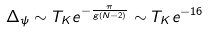<formula> <loc_0><loc_0><loc_500><loc_500>\Delta _ { \psi } \sim T _ { K } e ^ { - \frac { \pi } { g ( N - 2 ) } } \sim T _ { K } e ^ { - 1 6 }</formula> 